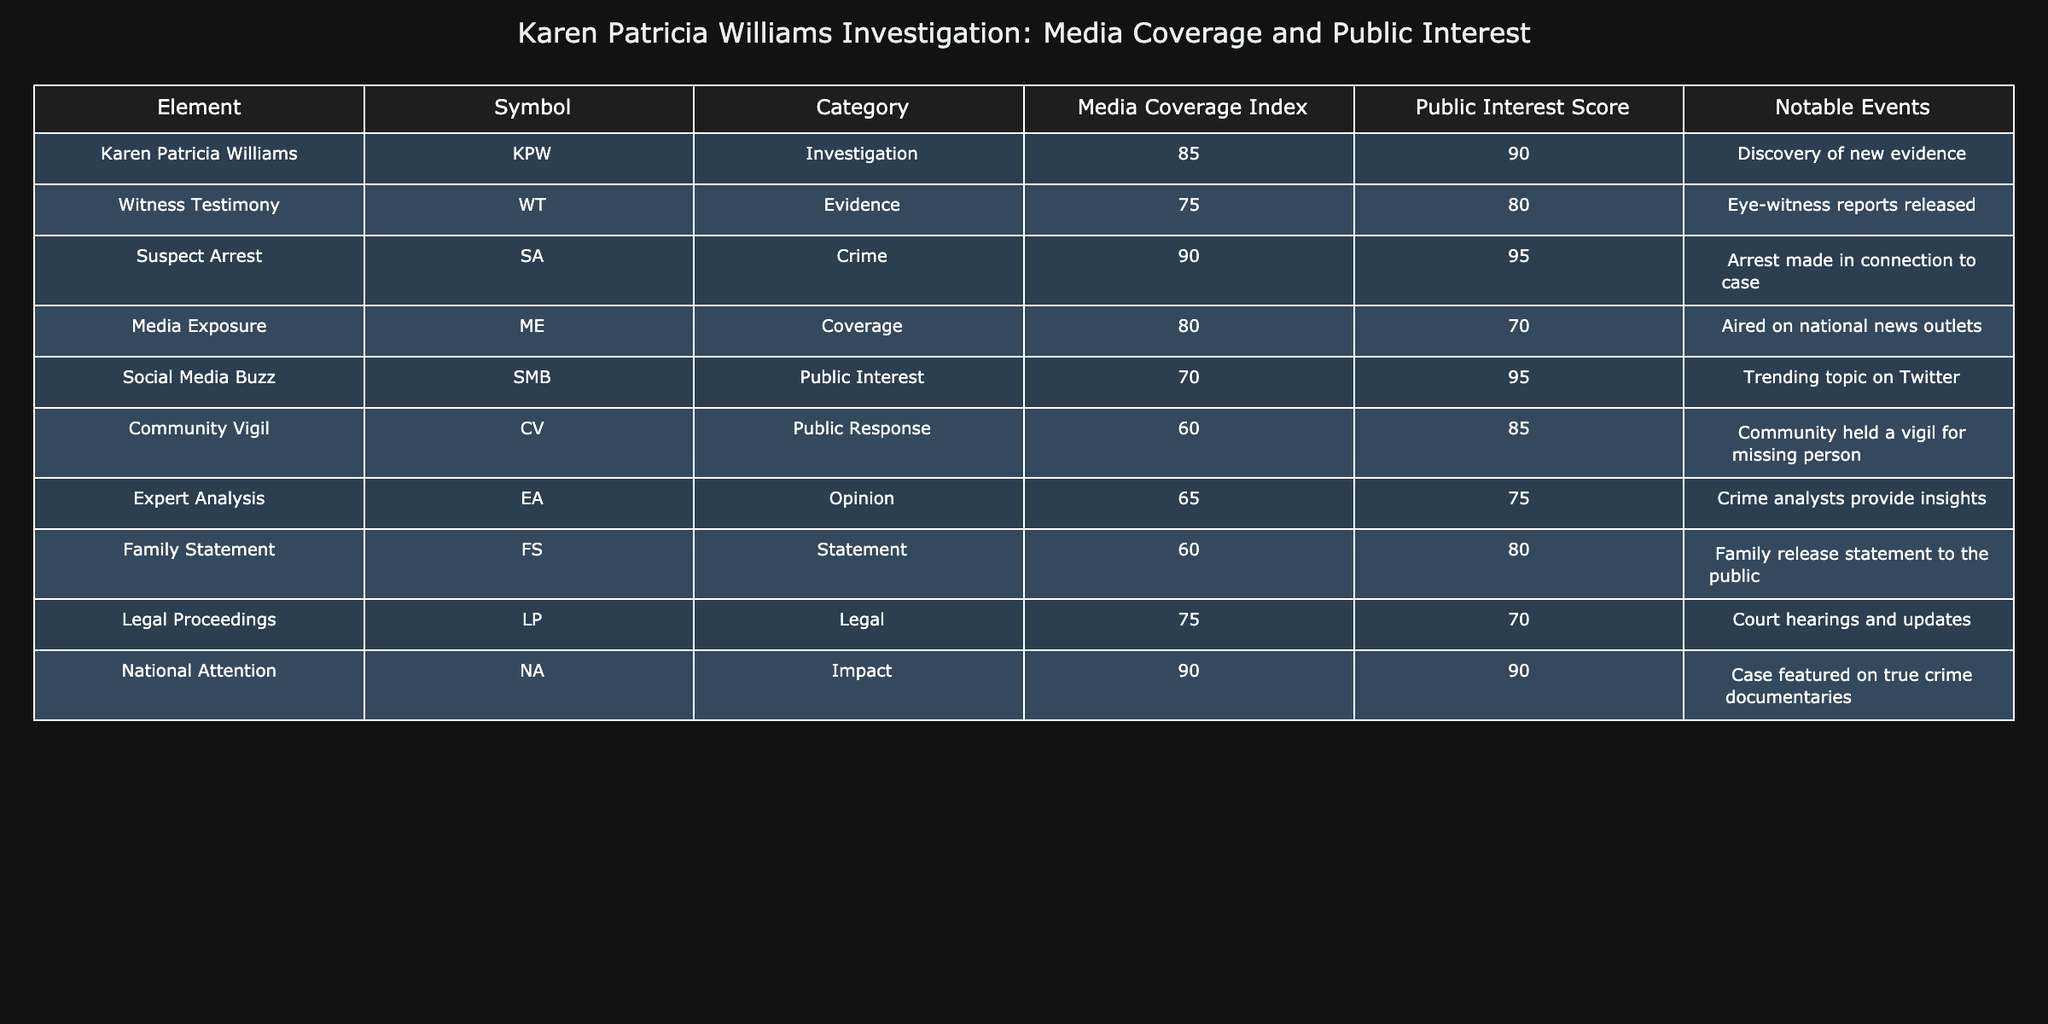What is the Media Coverage Index of the "Suspect Arrest"? From the table, the Media Coverage Index for "Suspect Arrest" is listed as 90. This value can be directly retrieved from the corresponding row under the Media Coverage Index column.
Answer: 90 What is the Public Interest Score for "Karen Patricia Williams"? According to the table, the Public Interest Score for "Karen Patricia Williams" is 90, found in the Public Interest Score column of her respective row.
Answer: 90 Is there a higher Media Coverage Index for "Media Exposure" or "Community Vigil"? "Media Exposure" has a Media Coverage Index of 80, while "Community Vigil" has a Media Coverage Index of 60. Since 80 is greater than 60, "Media Exposure" has a higher index. This is confirmed by comparing the respective values in the Media Coverage Index column.
Answer: Yes What is the average Public Interest Score for the "Evidence" and "Statement" categories? The Public Interest Scores for "Evidence" (75) and "Statement" (60) can be averaged. To find the average, sum these scores: 75 + 60 = 135. Then, divide by the number of elements (2), resulting in an average of 135 / 2 = 67.5.
Answer: 67.5 Which event has the highest Public Interest Score and what is the score? By examining the Public Interest Scores in the table, "Suspect Arrest" (95) holds the highest score. This is determined by scanning through all the Public Interest Scores and identifying the maximum.
Answer: 95 What is the total Media Coverage Index for all events related to the "Investigation" category? The Media Coverage Index values for the "Investigation" category include "Karen Patricia Williams" (85) and "Witness Testimony" (75). To get the total, we sum these values: 85 + 75 = 160. This process involves adding the relevant Media Coverage Index numbers directly.
Answer: 160 Does "Social Media Buzz" have a higher Public Interest Score than "Expert Analysis"? "Social Media Buzz" has a Public Interest Score of 95, while "Expert Analysis" has a score of 75. Since 95 is greater than 75, it confirms that "Social Media Buzz" has a higher score. This comparison is made by looking at both scores in the Public Interest Score column.
Answer: Yes What is the difference in Media Coverage Index between "National Attention" and "Legal Proceedings"? The Media Coverage Index for "National Attention" is 90, and for "Legal Proceedings," it is 75. To find the difference, subtract the lower value from the higher value: 90 - 75 = 15. This calculation involves two simple steps: identifying the values and subtracting them.
Answer: 15 